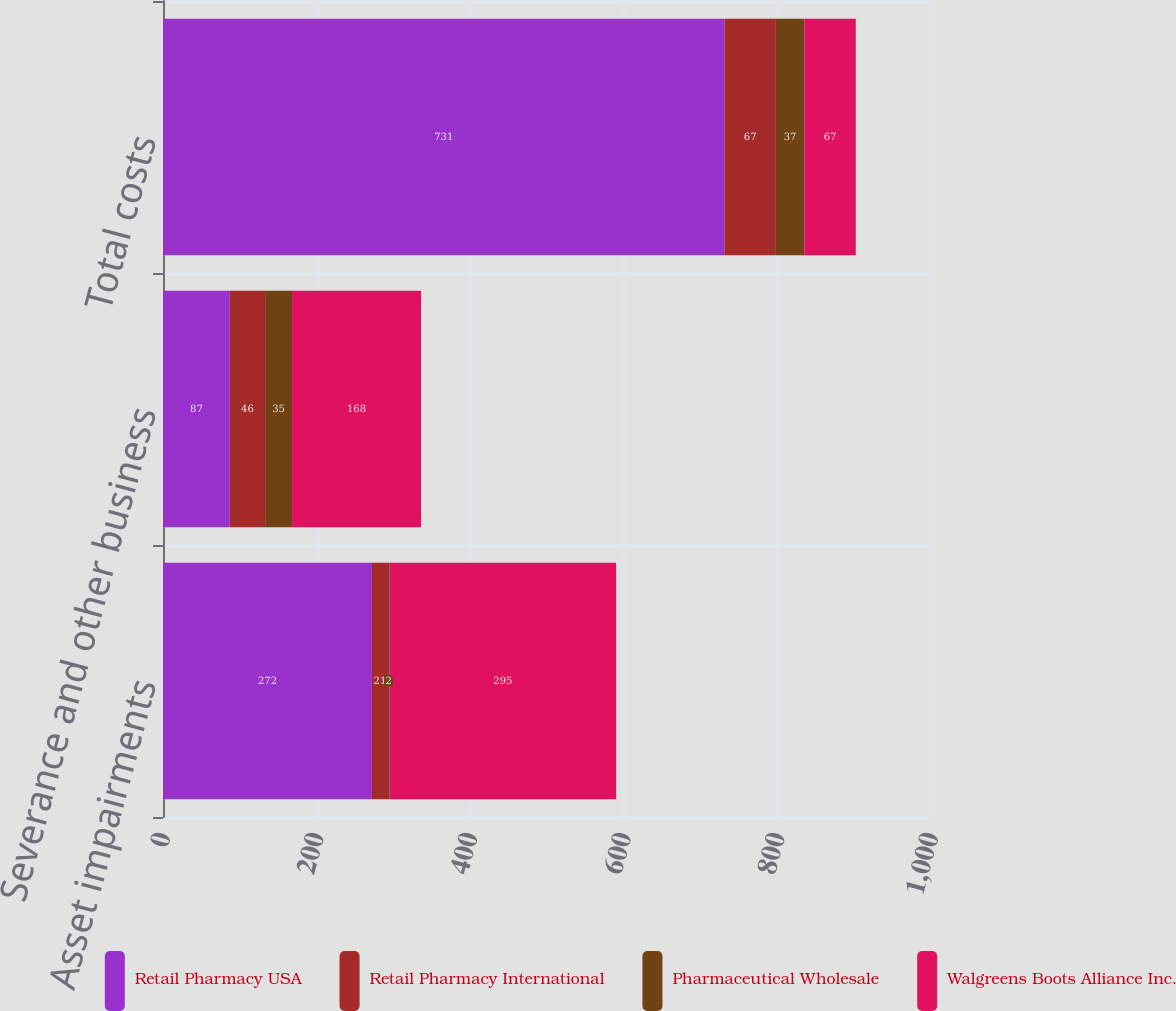<chart> <loc_0><loc_0><loc_500><loc_500><stacked_bar_chart><ecel><fcel>Asset impairments<fcel>Severance and other business<fcel>Total costs<nl><fcel>Retail Pharmacy USA<fcel>272<fcel>87<fcel>731<nl><fcel>Retail Pharmacy International<fcel>21<fcel>46<fcel>67<nl><fcel>Pharmaceutical Wholesale<fcel>2<fcel>35<fcel>37<nl><fcel>Walgreens Boots Alliance Inc.<fcel>295<fcel>168<fcel>67<nl></chart> 